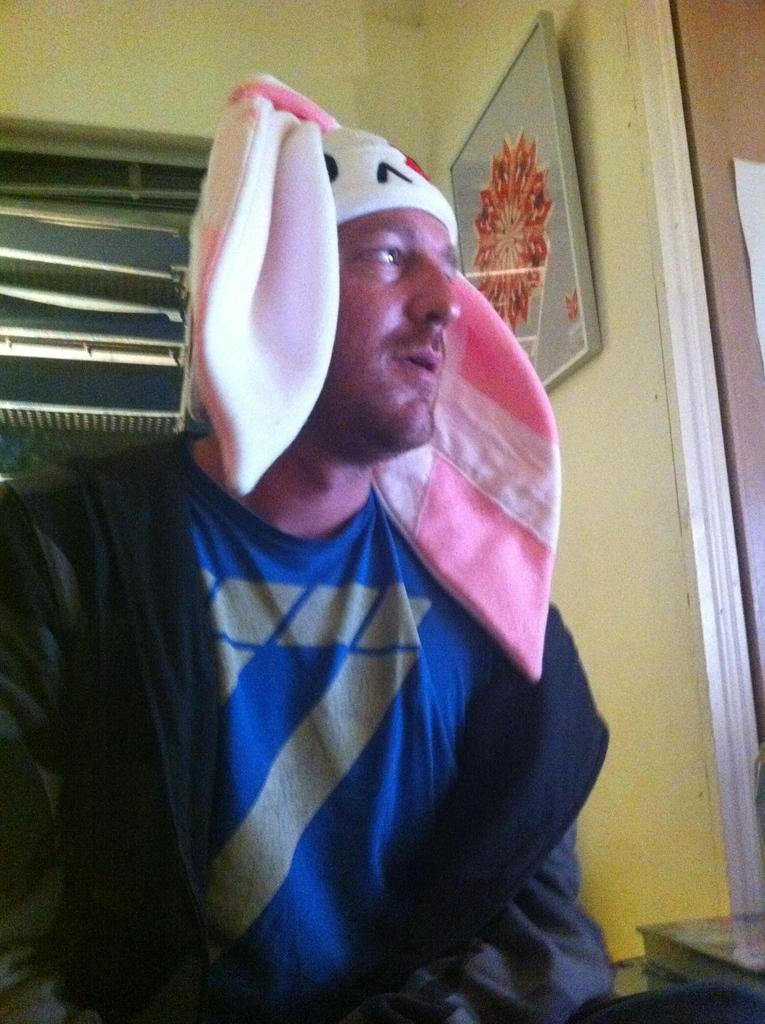Who is present in the image? There is a man in the image. What is the man wearing on his head? The man is wearing a cap. What can be seen in the background of the image? There is a ventilation system and a plain wall visible in the background. Is there any additional structure or object attached to the plain wall? Yes, a frame is attached to the plain wall. What else can be seen in the image? There is a paper present in the image. What type of disease is the man suffering from in the image? There is no indication of any disease in the image; the man appears to be wearing a cap and standing in front of a plain wall. 